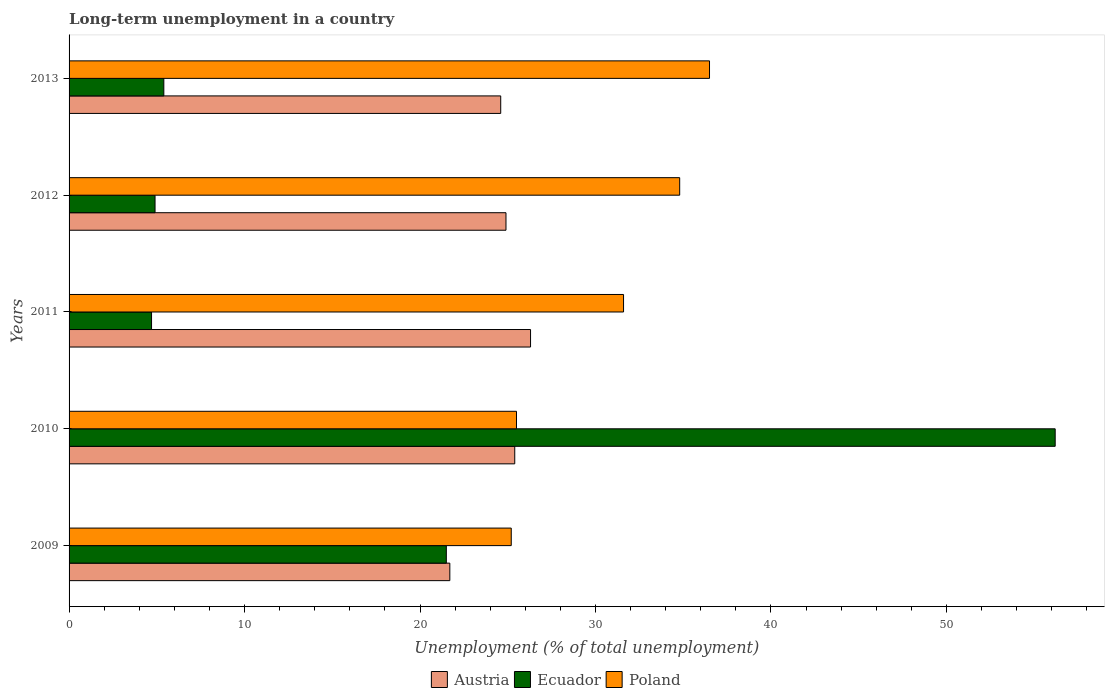How many groups of bars are there?
Provide a short and direct response. 5. What is the label of the 5th group of bars from the top?
Provide a succinct answer. 2009. What is the percentage of long-term unemployed population in Poland in 2009?
Your answer should be very brief. 25.2. Across all years, what is the maximum percentage of long-term unemployed population in Ecuador?
Your answer should be compact. 56.2. Across all years, what is the minimum percentage of long-term unemployed population in Ecuador?
Keep it short and to the point. 4.7. In which year was the percentage of long-term unemployed population in Poland minimum?
Provide a succinct answer. 2009. What is the total percentage of long-term unemployed population in Ecuador in the graph?
Your response must be concise. 92.7. What is the difference between the percentage of long-term unemployed population in Austria in 2011 and that in 2013?
Keep it short and to the point. 1.7. What is the difference between the percentage of long-term unemployed population in Austria in 2009 and the percentage of long-term unemployed population in Poland in 2011?
Your response must be concise. -9.9. What is the average percentage of long-term unemployed population in Austria per year?
Provide a short and direct response. 24.58. What is the ratio of the percentage of long-term unemployed population in Austria in 2010 to that in 2012?
Provide a succinct answer. 1.02. Is the percentage of long-term unemployed population in Austria in 2009 less than that in 2013?
Provide a succinct answer. Yes. Is the difference between the percentage of long-term unemployed population in Austria in 2011 and 2012 greater than the difference between the percentage of long-term unemployed population in Poland in 2011 and 2012?
Your response must be concise. Yes. What is the difference between the highest and the second highest percentage of long-term unemployed population in Ecuador?
Ensure brevity in your answer.  34.7. What is the difference between the highest and the lowest percentage of long-term unemployed population in Poland?
Keep it short and to the point. 11.3. What does the 2nd bar from the top in 2013 represents?
Provide a succinct answer. Ecuador. What does the 3rd bar from the bottom in 2010 represents?
Provide a short and direct response. Poland. How many bars are there?
Give a very brief answer. 15. How many years are there in the graph?
Ensure brevity in your answer.  5. Are the values on the major ticks of X-axis written in scientific E-notation?
Give a very brief answer. No. Does the graph contain any zero values?
Offer a terse response. No. Does the graph contain grids?
Provide a short and direct response. No. Where does the legend appear in the graph?
Offer a very short reply. Bottom center. What is the title of the graph?
Your response must be concise. Long-term unemployment in a country. Does "Dominica" appear as one of the legend labels in the graph?
Ensure brevity in your answer.  No. What is the label or title of the X-axis?
Your response must be concise. Unemployment (% of total unemployment). What is the Unemployment (% of total unemployment) of Austria in 2009?
Your answer should be compact. 21.7. What is the Unemployment (% of total unemployment) of Poland in 2009?
Ensure brevity in your answer.  25.2. What is the Unemployment (% of total unemployment) of Austria in 2010?
Your response must be concise. 25.4. What is the Unemployment (% of total unemployment) of Ecuador in 2010?
Provide a succinct answer. 56.2. What is the Unemployment (% of total unemployment) in Poland in 2010?
Provide a succinct answer. 25.5. What is the Unemployment (% of total unemployment) of Austria in 2011?
Your response must be concise. 26.3. What is the Unemployment (% of total unemployment) of Ecuador in 2011?
Make the answer very short. 4.7. What is the Unemployment (% of total unemployment) of Poland in 2011?
Offer a terse response. 31.6. What is the Unemployment (% of total unemployment) of Austria in 2012?
Offer a very short reply. 24.9. What is the Unemployment (% of total unemployment) in Ecuador in 2012?
Give a very brief answer. 4.9. What is the Unemployment (% of total unemployment) of Poland in 2012?
Your response must be concise. 34.8. What is the Unemployment (% of total unemployment) of Austria in 2013?
Offer a terse response. 24.6. What is the Unemployment (% of total unemployment) of Ecuador in 2013?
Keep it short and to the point. 5.4. What is the Unemployment (% of total unemployment) of Poland in 2013?
Provide a succinct answer. 36.5. Across all years, what is the maximum Unemployment (% of total unemployment) in Austria?
Your answer should be very brief. 26.3. Across all years, what is the maximum Unemployment (% of total unemployment) in Ecuador?
Ensure brevity in your answer.  56.2. Across all years, what is the maximum Unemployment (% of total unemployment) of Poland?
Your answer should be compact. 36.5. Across all years, what is the minimum Unemployment (% of total unemployment) of Austria?
Make the answer very short. 21.7. Across all years, what is the minimum Unemployment (% of total unemployment) in Ecuador?
Your answer should be compact. 4.7. Across all years, what is the minimum Unemployment (% of total unemployment) of Poland?
Provide a short and direct response. 25.2. What is the total Unemployment (% of total unemployment) in Austria in the graph?
Provide a short and direct response. 122.9. What is the total Unemployment (% of total unemployment) in Ecuador in the graph?
Ensure brevity in your answer.  92.7. What is the total Unemployment (% of total unemployment) in Poland in the graph?
Your answer should be compact. 153.6. What is the difference between the Unemployment (% of total unemployment) of Austria in 2009 and that in 2010?
Keep it short and to the point. -3.7. What is the difference between the Unemployment (% of total unemployment) of Ecuador in 2009 and that in 2010?
Provide a succinct answer. -34.7. What is the difference between the Unemployment (% of total unemployment) of Austria in 2009 and that in 2011?
Offer a terse response. -4.6. What is the difference between the Unemployment (% of total unemployment) of Ecuador in 2009 and that in 2011?
Provide a short and direct response. 16.8. What is the difference between the Unemployment (% of total unemployment) of Poland in 2009 and that in 2012?
Keep it short and to the point. -9.6. What is the difference between the Unemployment (% of total unemployment) in Ecuador in 2010 and that in 2011?
Offer a terse response. 51.5. What is the difference between the Unemployment (% of total unemployment) in Poland in 2010 and that in 2011?
Keep it short and to the point. -6.1. What is the difference between the Unemployment (% of total unemployment) of Austria in 2010 and that in 2012?
Give a very brief answer. 0.5. What is the difference between the Unemployment (% of total unemployment) in Ecuador in 2010 and that in 2012?
Your answer should be compact. 51.3. What is the difference between the Unemployment (% of total unemployment) of Austria in 2010 and that in 2013?
Your response must be concise. 0.8. What is the difference between the Unemployment (% of total unemployment) in Ecuador in 2010 and that in 2013?
Keep it short and to the point. 50.8. What is the difference between the Unemployment (% of total unemployment) of Poland in 2010 and that in 2013?
Make the answer very short. -11. What is the difference between the Unemployment (% of total unemployment) in Ecuador in 2011 and that in 2012?
Provide a succinct answer. -0.2. What is the difference between the Unemployment (% of total unemployment) in Poland in 2011 and that in 2012?
Keep it short and to the point. -3.2. What is the difference between the Unemployment (% of total unemployment) of Poland in 2011 and that in 2013?
Your response must be concise. -4.9. What is the difference between the Unemployment (% of total unemployment) of Ecuador in 2012 and that in 2013?
Give a very brief answer. -0.5. What is the difference between the Unemployment (% of total unemployment) of Austria in 2009 and the Unemployment (% of total unemployment) of Ecuador in 2010?
Your answer should be very brief. -34.5. What is the difference between the Unemployment (% of total unemployment) of Austria in 2009 and the Unemployment (% of total unemployment) of Ecuador in 2011?
Provide a short and direct response. 17. What is the difference between the Unemployment (% of total unemployment) in Austria in 2009 and the Unemployment (% of total unemployment) in Poland in 2011?
Offer a terse response. -9.9. What is the difference between the Unemployment (% of total unemployment) of Ecuador in 2009 and the Unemployment (% of total unemployment) of Poland in 2011?
Make the answer very short. -10.1. What is the difference between the Unemployment (% of total unemployment) of Austria in 2009 and the Unemployment (% of total unemployment) of Poland in 2012?
Provide a short and direct response. -13.1. What is the difference between the Unemployment (% of total unemployment) in Austria in 2009 and the Unemployment (% of total unemployment) in Poland in 2013?
Offer a terse response. -14.8. What is the difference between the Unemployment (% of total unemployment) of Ecuador in 2009 and the Unemployment (% of total unemployment) of Poland in 2013?
Make the answer very short. -15. What is the difference between the Unemployment (% of total unemployment) in Austria in 2010 and the Unemployment (% of total unemployment) in Ecuador in 2011?
Your answer should be very brief. 20.7. What is the difference between the Unemployment (% of total unemployment) in Austria in 2010 and the Unemployment (% of total unemployment) in Poland in 2011?
Make the answer very short. -6.2. What is the difference between the Unemployment (% of total unemployment) in Ecuador in 2010 and the Unemployment (% of total unemployment) in Poland in 2011?
Provide a succinct answer. 24.6. What is the difference between the Unemployment (% of total unemployment) of Ecuador in 2010 and the Unemployment (% of total unemployment) of Poland in 2012?
Make the answer very short. 21.4. What is the difference between the Unemployment (% of total unemployment) of Austria in 2010 and the Unemployment (% of total unemployment) of Ecuador in 2013?
Your answer should be very brief. 20. What is the difference between the Unemployment (% of total unemployment) of Ecuador in 2010 and the Unemployment (% of total unemployment) of Poland in 2013?
Provide a succinct answer. 19.7. What is the difference between the Unemployment (% of total unemployment) in Austria in 2011 and the Unemployment (% of total unemployment) in Ecuador in 2012?
Provide a succinct answer. 21.4. What is the difference between the Unemployment (% of total unemployment) of Ecuador in 2011 and the Unemployment (% of total unemployment) of Poland in 2012?
Provide a short and direct response. -30.1. What is the difference between the Unemployment (% of total unemployment) in Austria in 2011 and the Unemployment (% of total unemployment) in Ecuador in 2013?
Offer a terse response. 20.9. What is the difference between the Unemployment (% of total unemployment) of Ecuador in 2011 and the Unemployment (% of total unemployment) of Poland in 2013?
Keep it short and to the point. -31.8. What is the difference between the Unemployment (% of total unemployment) in Austria in 2012 and the Unemployment (% of total unemployment) in Ecuador in 2013?
Give a very brief answer. 19.5. What is the difference between the Unemployment (% of total unemployment) of Ecuador in 2012 and the Unemployment (% of total unemployment) of Poland in 2013?
Your response must be concise. -31.6. What is the average Unemployment (% of total unemployment) in Austria per year?
Provide a short and direct response. 24.58. What is the average Unemployment (% of total unemployment) of Ecuador per year?
Offer a very short reply. 18.54. What is the average Unemployment (% of total unemployment) of Poland per year?
Provide a short and direct response. 30.72. In the year 2009, what is the difference between the Unemployment (% of total unemployment) of Austria and Unemployment (% of total unemployment) of Ecuador?
Give a very brief answer. 0.2. In the year 2010, what is the difference between the Unemployment (% of total unemployment) in Austria and Unemployment (% of total unemployment) in Ecuador?
Provide a short and direct response. -30.8. In the year 2010, what is the difference between the Unemployment (% of total unemployment) of Austria and Unemployment (% of total unemployment) of Poland?
Offer a very short reply. -0.1. In the year 2010, what is the difference between the Unemployment (% of total unemployment) of Ecuador and Unemployment (% of total unemployment) of Poland?
Offer a terse response. 30.7. In the year 2011, what is the difference between the Unemployment (% of total unemployment) in Austria and Unemployment (% of total unemployment) in Ecuador?
Make the answer very short. 21.6. In the year 2011, what is the difference between the Unemployment (% of total unemployment) of Ecuador and Unemployment (% of total unemployment) of Poland?
Make the answer very short. -26.9. In the year 2012, what is the difference between the Unemployment (% of total unemployment) of Austria and Unemployment (% of total unemployment) of Ecuador?
Keep it short and to the point. 20. In the year 2012, what is the difference between the Unemployment (% of total unemployment) in Ecuador and Unemployment (% of total unemployment) in Poland?
Ensure brevity in your answer.  -29.9. In the year 2013, what is the difference between the Unemployment (% of total unemployment) of Austria and Unemployment (% of total unemployment) of Poland?
Offer a terse response. -11.9. In the year 2013, what is the difference between the Unemployment (% of total unemployment) in Ecuador and Unemployment (% of total unemployment) in Poland?
Provide a succinct answer. -31.1. What is the ratio of the Unemployment (% of total unemployment) of Austria in 2009 to that in 2010?
Your answer should be very brief. 0.85. What is the ratio of the Unemployment (% of total unemployment) of Ecuador in 2009 to that in 2010?
Your response must be concise. 0.38. What is the ratio of the Unemployment (% of total unemployment) in Poland in 2009 to that in 2010?
Offer a very short reply. 0.99. What is the ratio of the Unemployment (% of total unemployment) of Austria in 2009 to that in 2011?
Your answer should be very brief. 0.83. What is the ratio of the Unemployment (% of total unemployment) of Ecuador in 2009 to that in 2011?
Make the answer very short. 4.57. What is the ratio of the Unemployment (% of total unemployment) of Poland in 2009 to that in 2011?
Provide a short and direct response. 0.8. What is the ratio of the Unemployment (% of total unemployment) in Austria in 2009 to that in 2012?
Provide a short and direct response. 0.87. What is the ratio of the Unemployment (% of total unemployment) in Ecuador in 2009 to that in 2012?
Your answer should be compact. 4.39. What is the ratio of the Unemployment (% of total unemployment) of Poland in 2009 to that in 2012?
Offer a very short reply. 0.72. What is the ratio of the Unemployment (% of total unemployment) in Austria in 2009 to that in 2013?
Your answer should be very brief. 0.88. What is the ratio of the Unemployment (% of total unemployment) in Ecuador in 2009 to that in 2013?
Ensure brevity in your answer.  3.98. What is the ratio of the Unemployment (% of total unemployment) in Poland in 2009 to that in 2013?
Make the answer very short. 0.69. What is the ratio of the Unemployment (% of total unemployment) of Austria in 2010 to that in 2011?
Your answer should be very brief. 0.97. What is the ratio of the Unemployment (% of total unemployment) of Ecuador in 2010 to that in 2011?
Your response must be concise. 11.96. What is the ratio of the Unemployment (% of total unemployment) in Poland in 2010 to that in 2011?
Your answer should be compact. 0.81. What is the ratio of the Unemployment (% of total unemployment) in Austria in 2010 to that in 2012?
Offer a terse response. 1.02. What is the ratio of the Unemployment (% of total unemployment) of Ecuador in 2010 to that in 2012?
Your response must be concise. 11.47. What is the ratio of the Unemployment (% of total unemployment) in Poland in 2010 to that in 2012?
Give a very brief answer. 0.73. What is the ratio of the Unemployment (% of total unemployment) of Austria in 2010 to that in 2013?
Offer a very short reply. 1.03. What is the ratio of the Unemployment (% of total unemployment) in Ecuador in 2010 to that in 2013?
Your response must be concise. 10.41. What is the ratio of the Unemployment (% of total unemployment) in Poland in 2010 to that in 2013?
Your answer should be very brief. 0.7. What is the ratio of the Unemployment (% of total unemployment) of Austria in 2011 to that in 2012?
Give a very brief answer. 1.06. What is the ratio of the Unemployment (% of total unemployment) in Ecuador in 2011 to that in 2012?
Offer a terse response. 0.96. What is the ratio of the Unemployment (% of total unemployment) in Poland in 2011 to that in 2012?
Ensure brevity in your answer.  0.91. What is the ratio of the Unemployment (% of total unemployment) in Austria in 2011 to that in 2013?
Make the answer very short. 1.07. What is the ratio of the Unemployment (% of total unemployment) in Ecuador in 2011 to that in 2013?
Offer a terse response. 0.87. What is the ratio of the Unemployment (% of total unemployment) in Poland in 2011 to that in 2013?
Keep it short and to the point. 0.87. What is the ratio of the Unemployment (% of total unemployment) in Austria in 2012 to that in 2013?
Give a very brief answer. 1.01. What is the ratio of the Unemployment (% of total unemployment) in Ecuador in 2012 to that in 2013?
Provide a succinct answer. 0.91. What is the ratio of the Unemployment (% of total unemployment) of Poland in 2012 to that in 2013?
Your answer should be very brief. 0.95. What is the difference between the highest and the second highest Unemployment (% of total unemployment) in Ecuador?
Provide a succinct answer. 34.7. What is the difference between the highest and the lowest Unemployment (% of total unemployment) in Austria?
Offer a very short reply. 4.6. What is the difference between the highest and the lowest Unemployment (% of total unemployment) in Ecuador?
Offer a terse response. 51.5. What is the difference between the highest and the lowest Unemployment (% of total unemployment) of Poland?
Offer a very short reply. 11.3. 